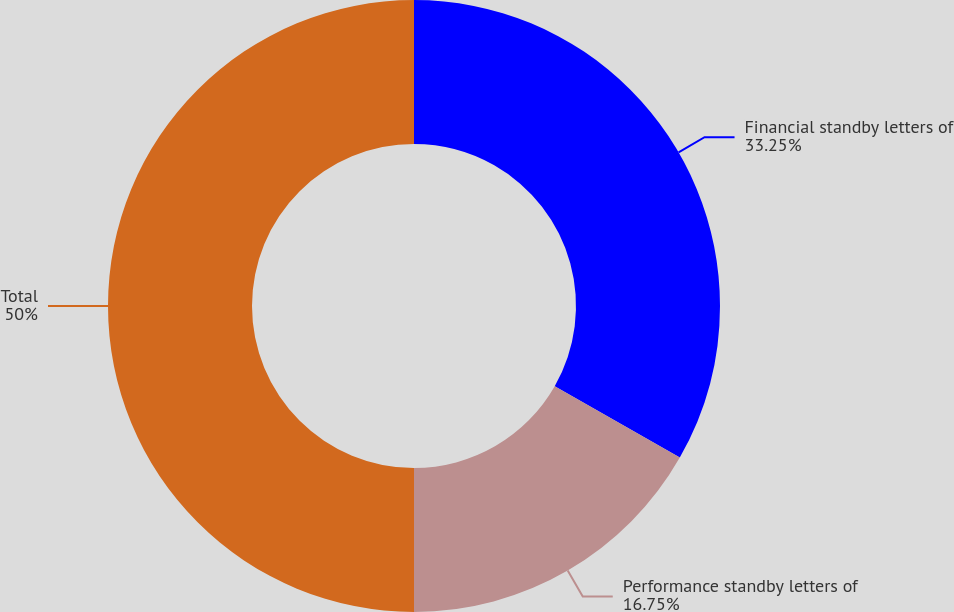Convert chart. <chart><loc_0><loc_0><loc_500><loc_500><pie_chart><fcel>Financial standby letters of<fcel>Performance standby letters of<fcel>Total<nl><fcel>33.25%<fcel>16.75%<fcel>50.0%<nl></chart> 